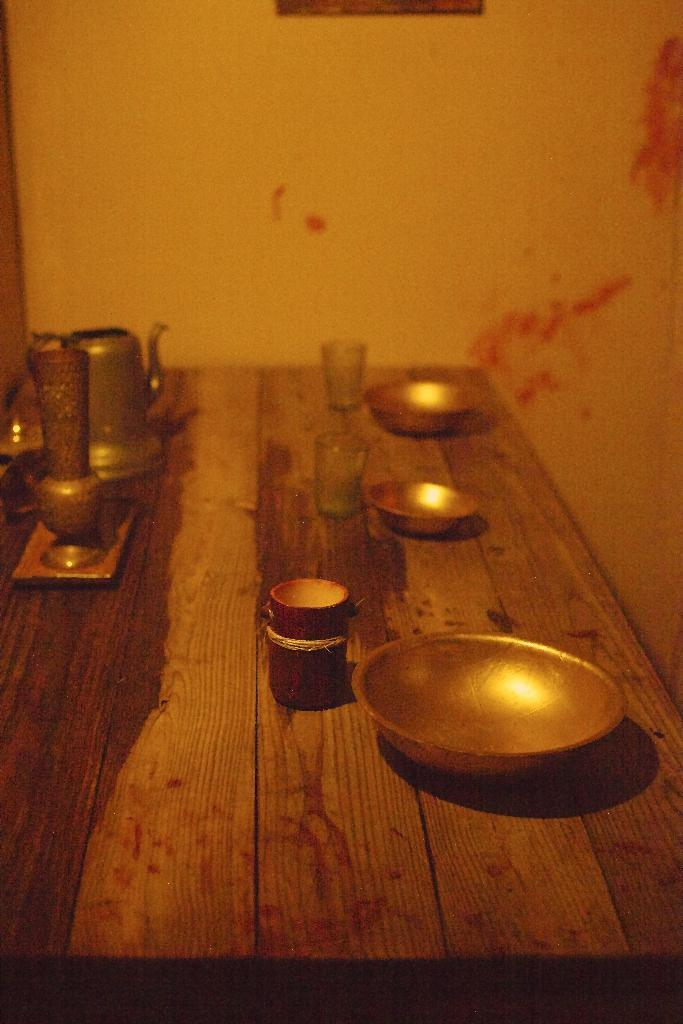What piece of furniture is present in the image? There is a table in the image. What objects are placed on the table? There are bowls, glasses, and jars on the table. What can be seen in the background of the image? There is a wall visible in the background of the image. What type of wool is being used to create the pattern on the tablecloth in the image? There is no tablecloth present in the image, so it is not possible to determine the type of wool being used. 